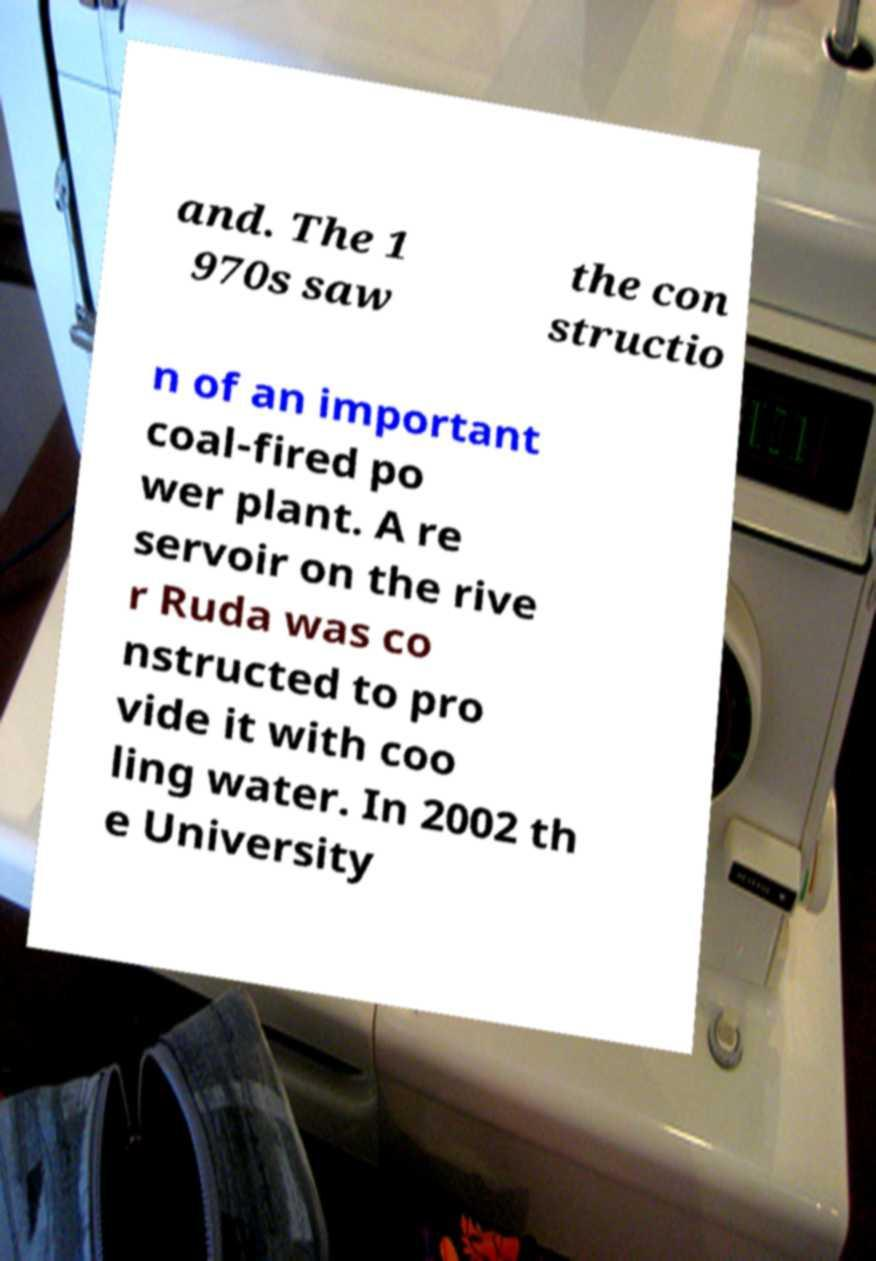There's text embedded in this image that I need extracted. Can you transcribe it verbatim? and. The 1 970s saw the con structio n of an important coal-fired po wer plant. A re servoir on the rive r Ruda was co nstructed to pro vide it with coo ling water. In 2002 th e University 